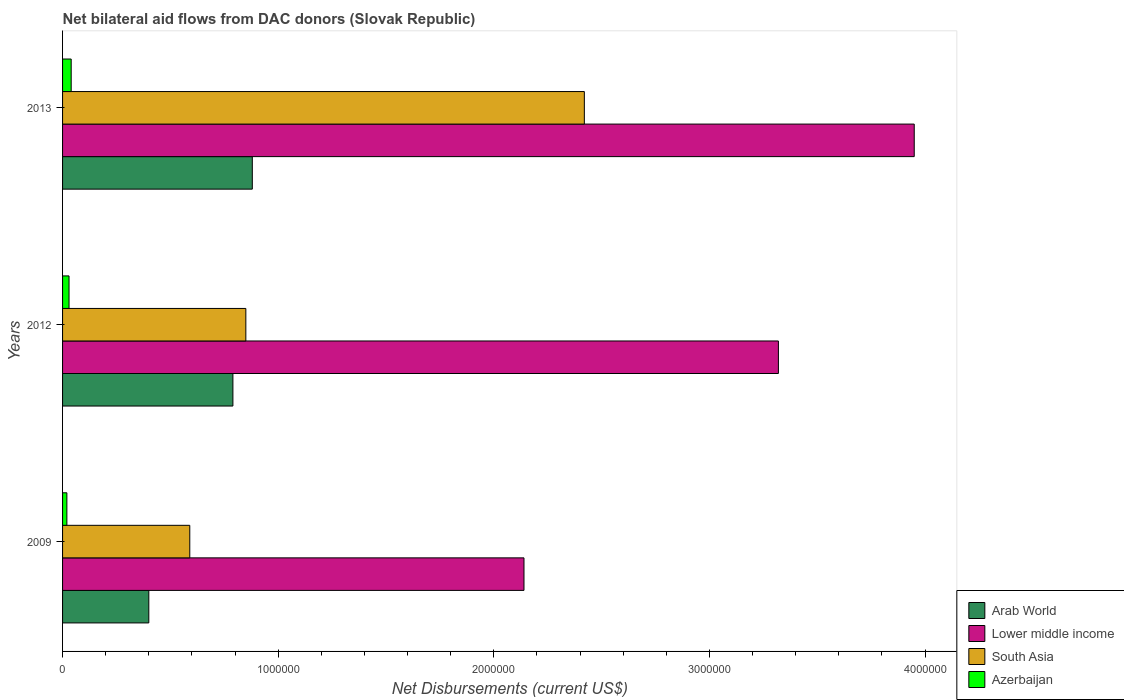Are the number of bars per tick equal to the number of legend labels?
Offer a very short reply. Yes. Are the number of bars on each tick of the Y-axis equal?
Give a very brief answer. Yes. How many bars are there on the 3rd tick from the top?
Your answer should be very brief. 4. How many bars are there on the 3rd tick from the bottom?
Offer a terse response. 4. What is the net bilateral aid flows in South Asia in 2013?
Your answer should be very brief. 2.42e+06. Across all years, what is the maximum net bilateral aid flows in South Asia?
Offer a very short reply. 2.42e+06. Across all years, what is the minimum net bilateral aid flows in Lower middle income?
Keep it short and to the point. 2.14e+06. In which year was the net bilateral aid flows in Lower middle income minimum?
Provide a succinct answer. 2009. What is the total net bilateral aid flows in Azerbaijan in the graph?
Your answer should be very brief. 9.00e+04. What is the difference between the net bilateral aid flows in Lower middle income in 2009 and that in 2013?
Keep it short and to the point. -1.81e+06. What is the difference between the net bilateral aid flows in Arab World in 2013 and the net bilateral aid flows in South Asia in 2012?
Your response must be concise. 3.00e+04. What is the average net bilateral aid flows in Lower middle income per year?
Offer a terse response. 3.14e+06. In the year 2013, what is the difference between the net bilateral aid flows in South Asia and net bilateral aid flows in Lower middle income?
Give a very brief answer. -1.53e+06. What is the ratio of the net bilateral aid flows in Azerbaijan in 2009 to that in 2012?
Offer a very short reply. 0.67. What is the difference between the highest and the second highest net bilateral aid flows in Lower middle income?
Offer a very short reply. 6.30e+05. What is the difference between the highest and the lowest net bilateral aid flows in Lower middle income?
Provide a short and direct response. 1.81e+06. In how many years, is the net bilateral aid flows in Lower middle income greater than the average net bilateral aid flows in Lower middle income taken over all years?
Your answer should be very brief. 2. What does the 4th bar from the top in 2009 represents?
Provide a succinct answer. Arab World. What does the 1st bar from the bottom in 2013 represents?
Provide a short and direct response. Arab World. Is it the case that in every year, the sum of the net bilateral aid flows in Azerbaijan and net bilateral aid flows in Arab World is greater than the net bilateral aid flows in South Asia?
Your response must be concise. No. Are all the bars in the graph horizontal?
Provide a succinct answer. Yes. Are the values on the major ticks of X-axis written in scientific E-notation?
Provide a succinct answer. No. Does the graph contain any zero values?
Offer a very short reply. No. Does the graph contain grids?
Ensure brevity in your answer.  No. How are the legend labels stacked?
Your answer should be very brief. Vertical. What is the title of the graph?
Make the answer very short. Net bilateral aid flows from DAC donors (Slovak Republic). Does "Iceland" appear as one of the legend labels in the graph?
Your answer should be compact. No. What is the label or title of the X-axis?
Ensure brevity in your answer.  Net Disbursements (current US$). What is the label or title of the Y-axis?
Offer a terse response. Years. What is the Net Disbursements (current US$) of Arab World in 2009?
Your answer should be compact. 4.00e+05. What is the Net Disbursements (current US$) in Lower middle income in 2009?
Your answer should be compact. 2.14e+06. What is the Net Disbursements (current US$) of South Asia in 2009?
Provide a succinct answer. 5.90e+05. What is the Net Disbursements (current US$) of Azerbaijan in 2009?
Your answer should be compact. 2.00e+04. What is the Net Disbursements (current US$) in Arab World in 2012?
Offer a very short reply. 7.90e+05. What is the Net Disbursements (current US$) in Lower middle income in 2012?
Provide a succinct answer. 3.32e+06. What is the Net Disbursements (current US$) in South Asia in 2012?
Offer a very short reply. 8.50e+05. What is the Net Disbursements (current US$) of Azerbaijan in 2012?
Your response must be concise. 3.00e+04. What is the Net Disbursements (current US$) in Arab World in 2013?
Make the answer very short. 8.80e+05. What is the Net Disbursements (current US$) in Lower middle income in 2013?
Your answer should be compact. 3.95e+06. What is the Net Disbursements (current US$) in South Asia in 2013?
Give a very brief answer. 2.42e+06. What is the Net Disbursements (current US$) of Azerbaijan in 2013?
Offer a very short reply. 4.00e+04. Across all years, what is the maximum Net Disbursements (current US$) in Arab World?
Give a very brief answer. 8.80e+05. Across all years, what is the maximum Net Disbursements (current US$) of Lower middle income?
Provide a short and direct response. 3.95e+06. Across all years, what is the maximum Net Disbursements (current US$) in South Asia?
Ensure brevity in your answer.  2.42e+06. Across all years, what is the minimum Net Disbursements (current US$) of Arab World?
Ensure brevity in your answer.  4.00e+05. Across all years, what is the minimum Net Disbursements (current US$) in Lower middle income?
Offer a terse response. 2.14e+06. Across all years, what is the minimum Net Disbursements (current US$) in South Asia?
Provide a succinct answer. 5.90e+05. Across all years, what is the minimum Net Disbursements (current US$) in Azerbaijan?
Ensure brevity in your answer.  2.00e+04. What is the total Net Disbursements (current US$) in Arab World in the graph?
Give a very brief answer. 2.07e+06. What is the total Net Disbursements (current US$) in Lower middle income in the graph?
Your answer should be very brief. 9.41e+06. What is the total Net Disbursements (current US$) of South Asia in the graph?
Provide a short and direct response. 3.86e+06. What is the total Net Disbursements (current US$) in Azerbaijan in the graph?
Your response must be concise. 9.00e+04. What is the difference between the Net Disbursements (current US$) in Arab World in 2009 and that in 2012?
Give a very brief answer. -3.90e+05. What is the difference between the Net Disbursements (current US$) in Lower middle income in 2009 and that in 2012?
Provide a succinct answer. -1.18e+06. What is the difference between the Net Disbursements (current US$) in Arab World in 2009 and that in 2013?
Ensure brevity in your answer.  -4.80e+05. What is the difference between the Net Disbursements (current US$) of Lower middle income in 2009 and that in 2013?
Offer a terse response. -1.81e+06. What is the difference between the Net Disbursements (current US$) in South Asia in 2009 and that in 2013?
Offer a terse response. -1.83e+06. What is the difference between the Net Disbursements (current US$) of Arab World in 2012 and that in 2013?
Offer a very short reply. -9.00e+04. What is the difference between the Net Disbursements (current US$) of Lower middle income in 2012 and that in 2013?
Offer a terse response. -6.30e+05. What is the difference between the Net Disbursements (current US$) of South Asia in 2012 and that in 2013?
Give a very brief answer. -1.57e+06. What is the difference between the Net Disbursements (current US$) of Arab World in 2009 and the Net Disbursements (current US$) of Lower middle income in 2012?
Keep it short and to the point. -2.92e+06. What is the difference between the Net Disbursements (current US$) of Arab World in 2009 and the Net Disbursements (current US$) of South Asia in 2012?
Your answer should be very brief. -4.50e+05. What is the difference between the Net Disbursements (current US$) of Arab World in 2009 and the Net Disbursements (current US$) of Azerbaijan in 2012?
Offer a terse response. 3.70e+05. What is the difference between the Net Disbursements (current US$) in Lower middle income in 2009 and the Net Disbursements (current US$) in South Asia in 2012?
Give a very brief answer. 1.29e+06. What is the difference between the Net Disbursements (current US$) of Lower middle income in 2009 and the Net Disbursements (current US$) of Azerbaijan in 2012?
Offer a very short reply. 2.11e+06. What is the difference between the Net Disbursements (current US$) of South Asia in 2009 and the Net Disbursements (current US$) of Azerbaijan in 2012?
Your answer should be compact. 5.60e+05. What is the difference between the Net Disbursements (current US$) of Arab World in 2009 and the Net Disbursements (current US$) of Lower middle income in 2013?
Your response must be concise. -3.55e+06. What is the difference between the Net Disbursements (current US$) of Arab World in 2009 and the Net Disbursements (current US$) of South Asia in 2013?
Give a very brief answer. -2.02e+06. What is the difference between the Net Disbursements (current US$) in Lower middle income in 2009 and the Net Disbursements (current US$) in South Asia in 2013?
Provide a short and direct response. -2.80e+05. What is the difference between the Net Disbursements (current US$) of Lower middle income in 2009 and the Net Disbursements (current US$) of Azerbaijan in 2013?
Your answer should be very brief. 2.10e+06. What is the difference between the Net Disbursements (current US$) of Arab World in 2012 and the Net Disbursements (current US$) of Lower middle income in 2013?
Offer a terse response. -3.16e+06. What is the difference between the Net Disbursements (current US$) in Arab World in 2012 and the Net Disbursements (current US$) in South Asia in 2013?
Make the answer very short. -1.63e+06. What is the difference between the Net Disbursements (current US$) in Arab World in 2012 and the Net Disbursements (current US$) in Azerbaijan in 2013?
Offer a terse response. 7.50e+05. What is the difference between the Net Disbursements (current US$) of Lower middle income in 2012 and the Net Disbursements (current US$) of Azerbaijan in 2013?
Provide a short and direct response. 3.28e+06. What is the difference between the Net Disbursements (current US$) in South Asia in 2012 and the Net Disbursements (current US$) in Azerbaijan in 2013?
Make the answer very short. 8.10e+05. What is the average Net Disbursements (current US$) of Arab World per year?
Offer a terse response. 6.90e+05. What is the average Net Disbursements (current US$) of Lower middle income per year?
Your response must be concise. 3.14e+06. What is the average Net Disbursements (current US$) of South Asia per year?
Your answer should be very brief. 1.29e+06. What is the average Net Disbursements (current US$) in Azerbaijan per year?
Provide a succinct answer. 3.00e+04. In the year 2009, what is the difference between the Net Disbursements (current US$) in Arab World and Net Disbursements (current US$) in Lower middle income?
Offer a very short reply. -1.74e+06. In the year 2009, what is the difference between the Net Disbursements (current US$) in Arab World and Net Disbursements (current US$) in South Asia?
Offer a terse response. -1.90e+05. In the year 2009, what is the difference between the Net Disbursements (current US$) in Lower middle income and Net Disbursements (current US$) in South Asia?
Provide a succinct answer. 1.55e+06. In the year 2009, what is the difference between the Net Disbursements (current US$) of Lower middle income and Net Disbursements (current US$) of Azerbaijan?
Provide a short and direct response. 2.12e+06. In the year 2009, what is the difference between the Net Disbursements (current US$) of South Asia and Net Disbursements (current US$) of Azerbaijan?
Offer a terse response. 5.70e+05. In the year 2012, what is the difference between the Net Disbursements (current US$) of Arab World and Net Disbursements (current US$) of Lower middle income?
Make the answer very short. -2.53e+06. In the year 2012, what is the difference between the Net Disbursements (current US$) in Arab World and Net Disbursements (current US$) in South Asia?
Offer a terse response. -6.00e+04. In the year 2012, what is the difference between the Net Disbursements (current US$) in Arab World and Net Disbursements (current US$) in Azerbaijan?
Offer a terse response. 7.60e+05. In the year 2012, what is the difference between the Net Disbursements (current US$) in Lower middle income and Net Disbursements (current US$) in South Asia?
Offer a terse response. 2.47e+06. In the year 2012, what is the difference between the Net Disbursements (current US$) of Lower middle income and Net Disbursements (current US$) of Azerbaijan?
Your response must be concise. 3.29e+06. In the year 2012, what is the difference between the Net Disbursements (current US$) in South Asia and Net Disbursements (current US$) in Azerbaijan?
Ensure brevity in your answer.  8.20e+05. In the year 2013, what is the difference between the Net Disbursements (current US$) in Arab World and Net Disbursements (current US$) in Lower middle income?
Ensure brevity in your answer.  -3.07e+06. In the year 2013, what is the difference between the Net Disbursements (current US$) of Arab World and Net Disbursements (current US$) of South Asia?
Make the answer very short. -1.54e+06. In the year 2013, what is the difference between the Net Disbursements (current US$) of Arab World and Net Disbursements (current US$) of Azerbaijan?
Provide a short and direct response. 8.40e+05. In the year 2013, what is the difference between the Net Disbursements (current US$) in Lower middle income and Net Disbursements (current US$) in South Asia?
Your response must be concise. 1.53e+06. In the year 2013, what is the difference between the Net Disbursements (current US$) in Lower middle income and Net Disbursements (current US$) in Azerbaijan?
Your answer should be compact. 3.91e+06. In the year 2013, what is the difference between the Net Disbursements (current US$) in South Asia and Net Disbursements (current US$) in Azerbaijan?
Your response must be concise. 2.38e+06. What is the ratio of the Net Disbursements (current US$) in Arab World in 2009 to that in 2012?
Your answer should be very brief. 0.51. What is the ratio of the Net Disbursements (current US$) in Lower middle income in 2009 to that in 2012?
Your response must be concise. 0.64. What is the ratio of the Net Disbursements (current US$) in South Asia in 2009 to that in 2012?
Offer a terse response. 0.69. What is the ratio of the Net Disbursements (current US$) of Arab World in 2009 to that in 2013?
Keep it short and to the point. 0.45. What is the ratio of the Net Disbursements (current US$) in Lower middle income in 2009 to that in 2013?
Your answer should be very brief. 0.54. What is the ratio of the Net Disbursements (current US$) of South Asia in 2009 to that in 2013?
Offer a terse response. 0.24. What is the ratio of the Net Disbursements (current US$) of Arab World in 2012 to that in 2013?
Make the answer very short. 0.9. What is the ratio of the Net Disbursements (current US$) in Lower middle income in 2012 to that in 2013?
Provide a succinct answer. 0.84. What is the ratio of the Net Disbursements (current US$) in South Asia in 2012 to that in 2013?
Keep it short and to the point. 0.35. What is the difference between the highest and the second highest Net Disbursements (current US$) of Lower middle income?
Offer a terse response. 6.30e+05. What is the difference between the highest and the second highest Net Disbursements (current US$) of South Asia?
Provide a succinct answer. 1.57e+06. What is the difference between the highest and the second highest Net Disbursements (current US$) in Azerbaijan?
Offer a terse response. 10000. What is the difference between the highest and the lowest Net Disbursements (current US$) of Arab World?
Your answer should be very brief. 4.80e+05. What is the difference between the highest and the lowest Net Disbursements (current US$) of Lower middle income?
Offer a terse response. 1.81e+06. What is the difference between the highest and the lowest Net Disbursements (current US$) in South Asia?
Ensure brevity in your answer.  1.83e+06. 